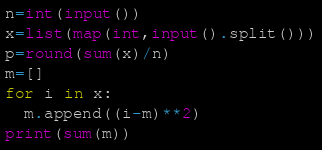Convert code to text. <code><loc_0><loc_0><loc_500><loc_500><_Python_>n=int(input())
x=list(map(int,input().split()))
p=round(sum(x)/n)
m=[]
for i in x:
  m.append((i-m)**2)
print(sum(m))</code> 